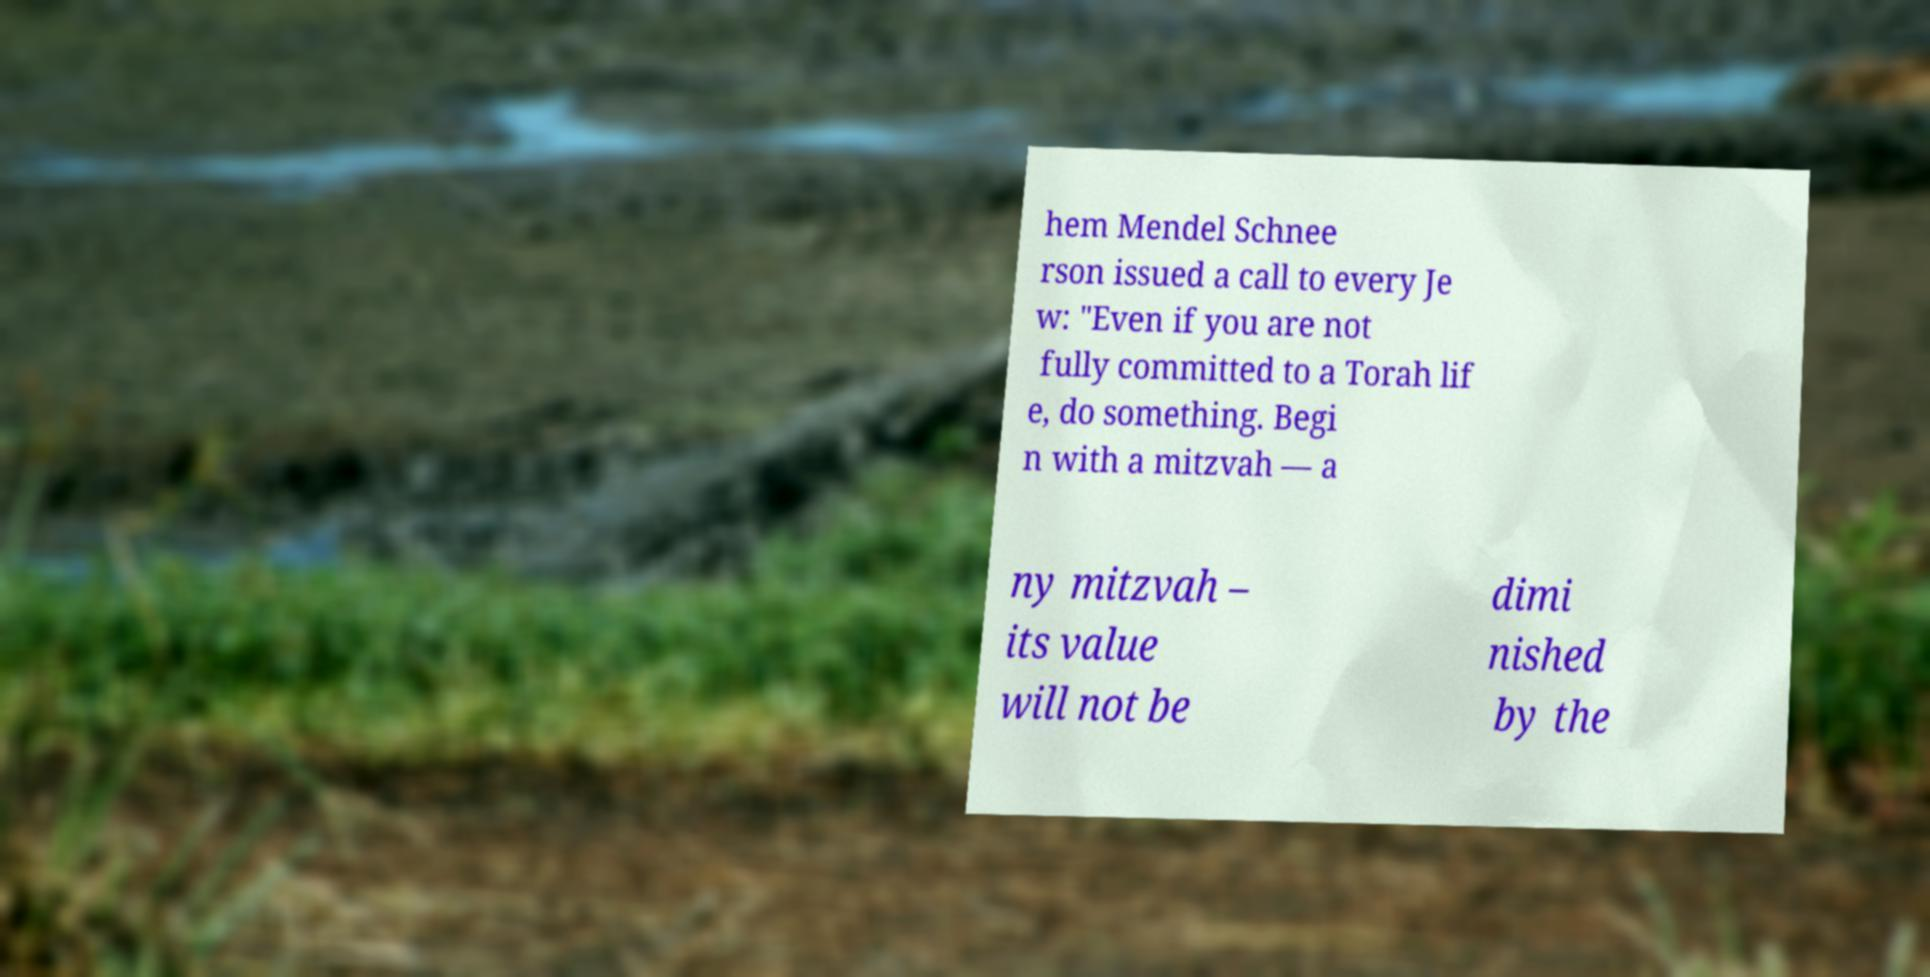There's text embedded in this image that I need extracted. Can you transcribe it verbatim? hem Mendel Schnee rson issued a call to every Je w: "Even if you are not fully committed to a Torah lif e, do something. Begi n with a mitzvah — a ny mitzvah – its value will not be dimi nished by the 